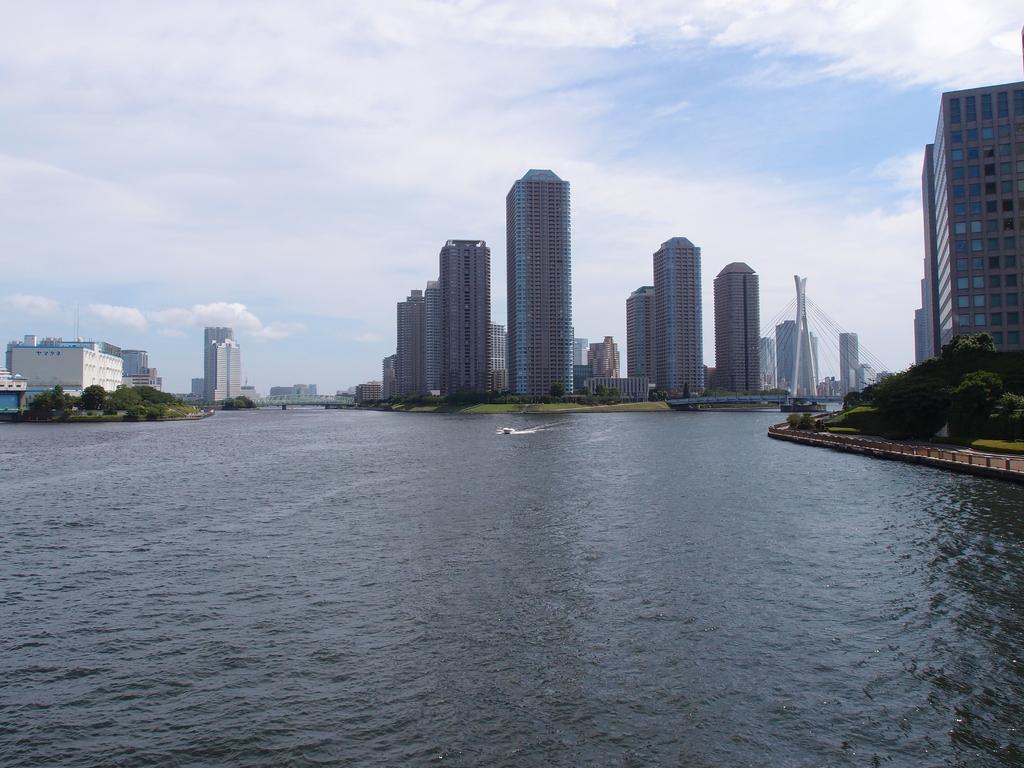Could you give a brief overview of what you see in this image? In this image we can see a few buildings, there are some trees, grass and water, in the water we can see the boats and in the background we can see the sky with clouds. 